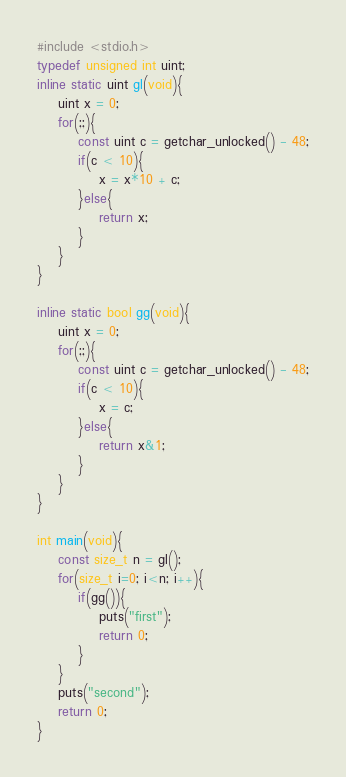<code> <loc_0><loc_0><loc_500><loc_500><_C_>#include <stdio.h>
typedef unsigned int uint;
inline static uint gl(void){
    uint x = 0;
    for(;;){
        const uint c = getchar_unlocked() - 48;
        if(c < 10){
            x = x*10 + c;
        }else{
            return x;
        }
    }
}

inline static bool gg(void){
    uint x = 0;
    for(;;){
        const uint c = getchar_unlocked() - 48;
        if(c < 10){
            x = c;
        }else{
            return x&1;
        }
    }
}

int main(void){
    const size_t n = gl();
    for(size_t i=0; i<n; i++){
        if(gg()){
            puts("first");
            return 0;
        }
    }
    puts("second");
    return 0;
}
</code> 